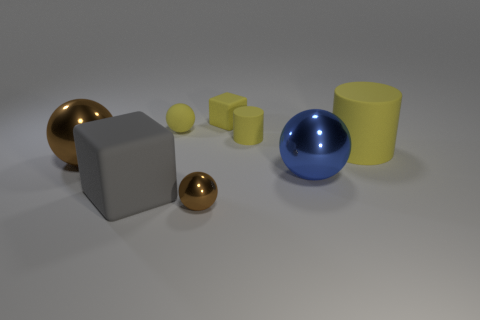How many other things are there of the same material as the large gray thing?
Keep it short and to the point. 4. What number of large yellow cylinders are in front of the tiny ball in front of the large yellow rubber cylinder?
Ensure brevity in your answer.  0. What number of cylinders are either big cyan metallic objects or small yellow things?
Keep it short and to the point. 1. There is a sphere that is in front of the large yellow cylinder and on the left side of the tiny shiny ball; what is its color?
Your answer should be compact. Brown. Is there anything else of the same color as the small cylinder?
Your answer should be compact. Yes. There is a small matte thing that is behind the ball that is behind the big cylinder; what is its color?
Keep it short and to the point. Yellow. Does the rubber ball have the same size as the blue shiny sphere?
Your response must be concise. No. Do the big ball to the left of the yellow rubber cube and the big ball in front of the large brown metal sphere have the same material?
Your answer should be very brief. Yes. There is a tiny thing to the left of the brown metal ball that is right of the metal object that is to the left of the yellow ball; what is its shape?
Your response must be concise. Sphere. Are there more big red cubes than big blue metal spheres?
Your answer should be compact. No. 